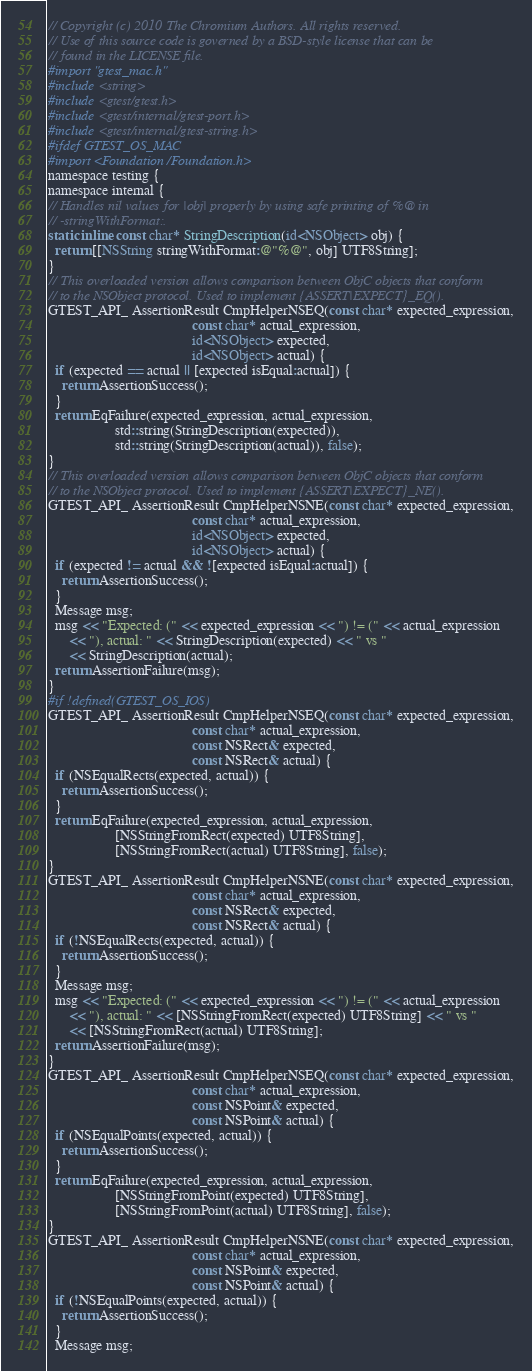Convert code to text. <code><loc_0><loc_0><loc_500><loc_500><_ObjectiveC_>// Copyright (c) 2010 The Chromium Authors. All rights reserved.
// Use of this source code is governed by a BSD-style license that can be
// found in the LICENSE file.
#import "gtest_mac.h"
#include <string>
#include <gtest/gtest.h>
#include <gtest/internal/gtest-port.h>
#include <gtest/internal/gtest-string.h>
#ifdef GTEST_OS_MAC
#import <Foundation/Foundation.h>
namespace testing {
namespace internal {
// Handles nil values for |obj| properly by using safe printing of %@ in
// -stringWithFormat:.
static inline const char* StringDescription(id<NSObject> obj) {
  return [[NSString stringWithFormat:@"%@", obj] UTF8String];
}
// This overloaded version allows comparison between ObjC objects that conform
// to the NSObject protocol. Used to implement {ASSERT|EXPECT}_EQ().
GTEST_API_ AssertionResult CmpHelperNSEQ(const char* expected_expression,
                                         const char* actual_expression,
                                         id<NSObject> expected,
                                         id<NSObject> actual) {
  if (expected == actual || [expected isEqual:actual]) {
    return AssertionSuccess();
  }
  return EqFailure(expected_expression, actual_expression,
                   std::string(StringDescription(expected)),
                   std::string(StringDescription(actual)), false);
}
// This overloaded version allows comparison between ObjC objects that conform
// to the NSObject protocol. Used to implement {ASSERT|EXPECT}_NE().
GTEST_API_ AssertionResult CmpHelperNSNE(const char* expected_expression,
                                         const char* actual_expression,
                                         id<NSObject> expected,
                                         id<NSObject> actual) {
  if (expected != actual && ![expected isEqual:actual]) {
    return AssertionSuccess();
  }
  Message msg;
  msg << "Expected: (" << expected_expression << ") != (" << actual_expression
      << "), actual: " << StringDescription(expected) << " vs "
      << StringDescription(actual);
  return AssertionFailure(msg);
}
#if !defined(GTEST_OS_IOS)
GTEST_API_ AssertionResult CmpHelperNSEQ(const char* expected_expression,
                                         const char* actual_expression,
                                         const NSRect& expected,
                                         const NSRect& actual) {
  if (NSEqualRects(expected, actual)) {
    return AssertionSuccess();
  }
  return EqFailure(expected_expression, actual_expression,
                   [NSStringFromRect(expected) UTF8String],
                   [NSStringFromRect(actual) UTF8String], false);
}
GTEST_API_ AssertionResult CmpHelperNSNE(const char* expected_expression,
                                         const char* actual_expression,
                                         const NSRect& expected,
                                         const NSRect& actual) {
  if (!NSEqualRects(expected, actual)) {
    return AssertionSuccess();
  }
  Message msg;
  msg << "Expected: (" << expected_expression << ") != (" << actual_expression
      << "), actual: " << [NSStringFromRect(expected) UTF8String] << " vs "
      << [NSStringFromRect(actual) UTF8String];
  return AssertionFailure(msg);
}
GTEST_API_ AssertionResult CmpHelperNSEQ(const char* expected_expression,
                                         const char* actual_expression,
                                         const NSPoint& expected,
                                         const NSPoint& actual) {
  if (NSEqualPoints(expected, actual)) {
    return AssertionSuccess();
  }
  return EqFailure(expected_expression, actual_expression,
                   [NSStringFromPoint(expected) UTF8String],
                   [NSStringFromPoint(actual) UTF8String], false);
}
GTEST_API_ AssertionResult CmpHelperNSNE(const char* expected_expression,
                                         const char* actual_expression,
                                         const NSPoint& expected,
                                         const NSPoint& actual) {
  if (!NSEqualPoints(expected, actual)) {
    return AssertionSuccess();
  }
  Message msg;</code> 